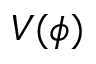<formula> <loc_0><loc_0><loc_500><loc_500>V ( \phi )</formula> 